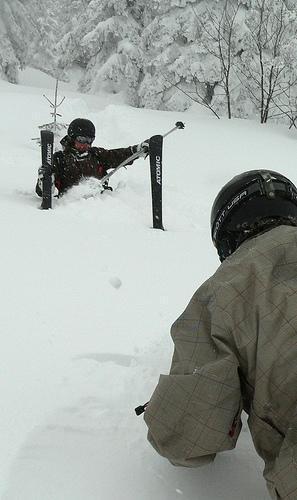How many people are in the picture?
Give a very brief answer. 2. How many skis do you see?
Give a very brief answer. 2. How many are in this image?
Give a very brief answer. 2. How many people can you see?
Give a very brief answer. 2. 